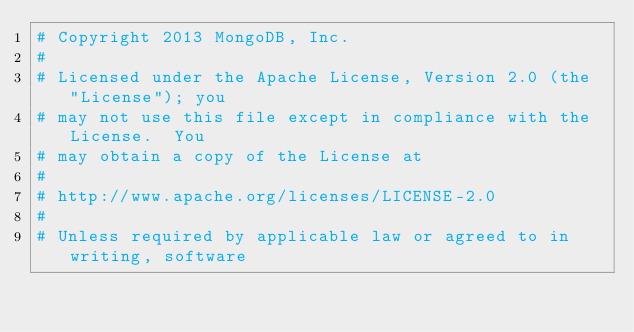Convert code to text. <code><loc_0><loc_0><loc_500><loc_500><_Python_># Copyright 2013 MongoDB, Inc.
#
# Licensed under the Apache License, Version 2.0 (the "License"); you
# may not use this file except in compliance with the License.  You
# may obtain a copy of the License at
#
# http://www.apache.org/licenses/LICENSE-2.0
#
# Unless required by applicable law or agreed to in writing, software</code> 